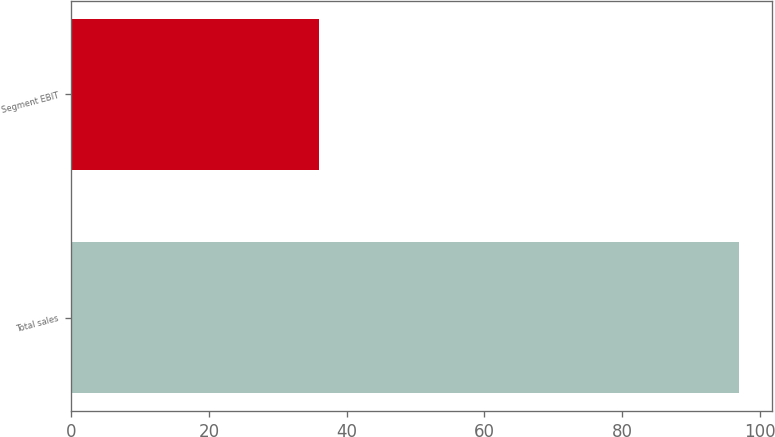<chart> <loc_0><loc_0><loc_500><loc_500><bar_chart><fcel>Total sales<fcel>Segment EBIT<nl><fcel>97<fcel>36<nl></chart> 